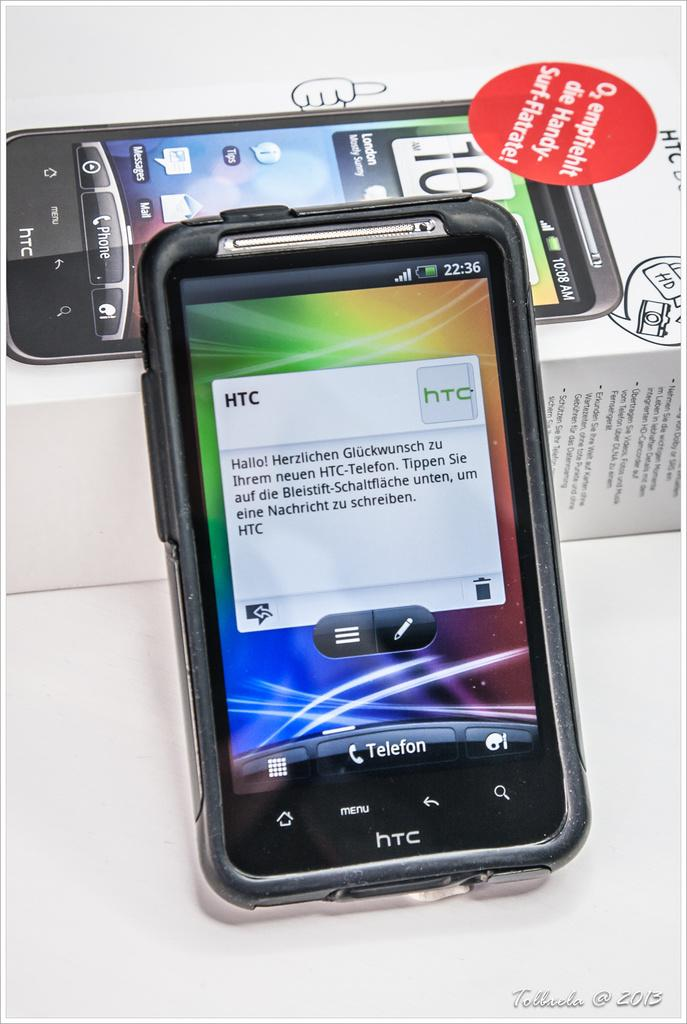<image>
Offer a succinct explanation of the picture presented. a box that says HTC at the top of it 